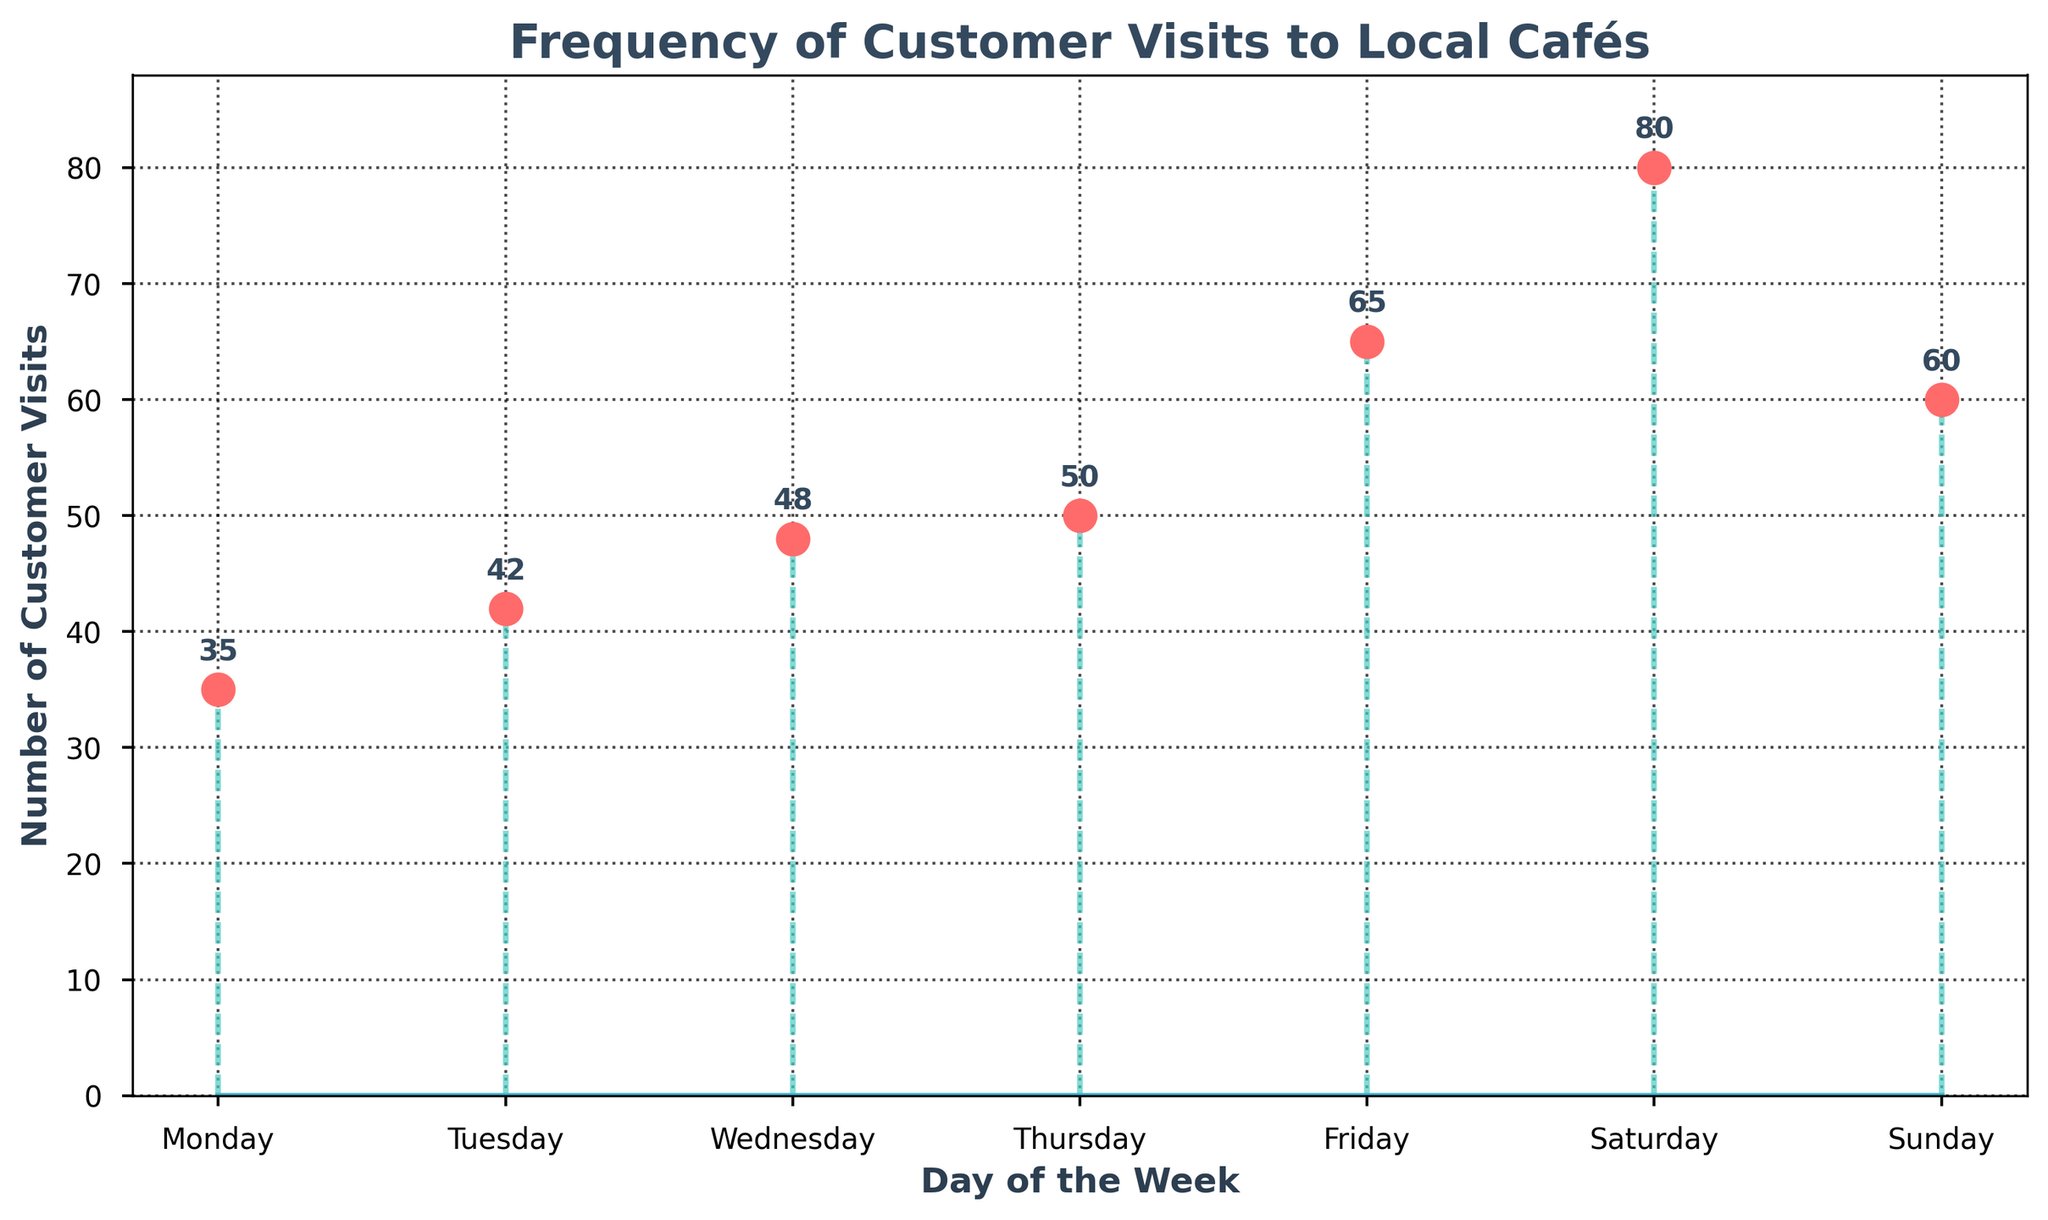What is the title of the figure? The title is typically found at the top center of the figure. In this case, the title is "Frequency of Customer Visits to Local Cafés".
Answer: Frequency of Customer Visits to Local Cafés On which day did the cafés receive the highest number of customer visits? Looking at the highest point on the stem plot, you can see that Saturday had the most visits with a value of 80.
Answer: Saturday How many customer visits did cafés receive on Monday? Check the plot for the value corresponding to Monday, which is indicated as 35.
Answer: 35 Which day had fewer customer visits: Monday or Thursday? Compare the stem lengths for Monday and Thursday. Monday has 35 visits, while Thursday has 50 visits. Monday is fewer.
Answer: Monday What is the total number of customer visits for the weekend (Saturday and Sunday)? Add the number of visits on Saturday (80) and Sunday (60). 80 + 60 = 140.
Answer: 140 What is the average number of customer visits per day? Sum the visits for all days (35 + 42 + 48 + 50 + 65 + 80 + 60 = 380) and divide by the number of days (7). 380 / 7 ≈ 54.29.
Answer: 54.29 Which two days have the closest number of customer visits? Compare the visit numbers for each day and find the closest pair. Wednesday (48) and Thursday (50) are closest with a difference of 2 visits.
Answer: Wednesday and Thursday Describe the trend in customer visits over the weekdays (Monday to Friday). Observing the plot from Monday to Friday, the number of visits consistently increases from 35 on Monday to 65 on Friday.
Answer: Increasing trend On average, how many more customer visits are there on weekends compared to weekdays? Compute the total visits for weekends (80 + 60 = 140) and weekdays (35 + 42 + 48 + 50 + 65 = 240). Calculate the averages: 140/2 = 70 (weekends) and 240/5 = 48 (weekdays). The difference is 70 - 48 = 22.
Answer: 22 Which day of the week has the median number of customer visits? List the visits in ascending order: [35, 42, 48, 50, 60, 65, 80]. The median is the middle value: 50, which corresponds to Thursday.
Answer: Thursday 